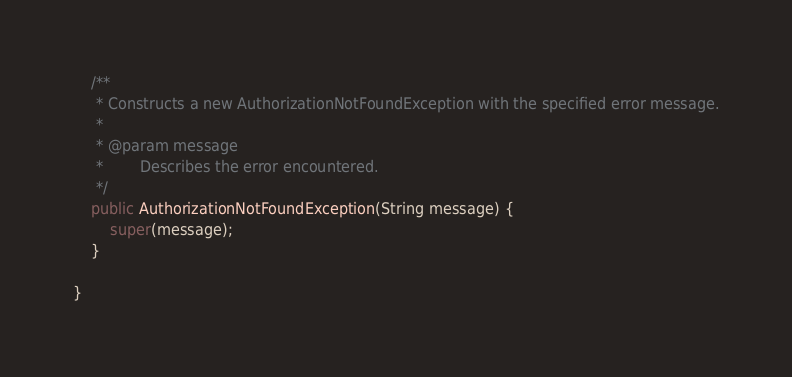Convert code to text. <code><loc_0><loc_0><loc_500><loc_500><_Java_>    /**
     * Constructs a new AuthorizationNotFoundException with the specified error message.
     *
     * @param message
     *        Describes the error encountered.
     */
    public AuthorizationNotFoundException(String message) {
        super(message);
    }

}
</code> 